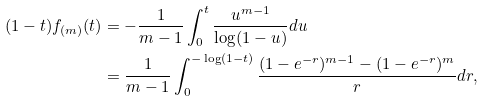<formula> <loc_0><loc_0><loc_500><loc_500>( 1 - t ) f _ { ( m ) } ( t ) & = - \frac { 1 } { m - 1 } \int _ { 0 } ^ { t } \frac { u ^ { m - 1 } } { \log ( 1 - u ) } d u \\ & = \frac { 1 } { m - 1 } \int _ { 0 } ^ { - \log ( 1 - t ) } \frac { ( 1 - e ^ { - r } ) ^ { m - 1 } - ( 1 - e ^ { - r } ) ^ { m } } { r } d r ,</formula> 